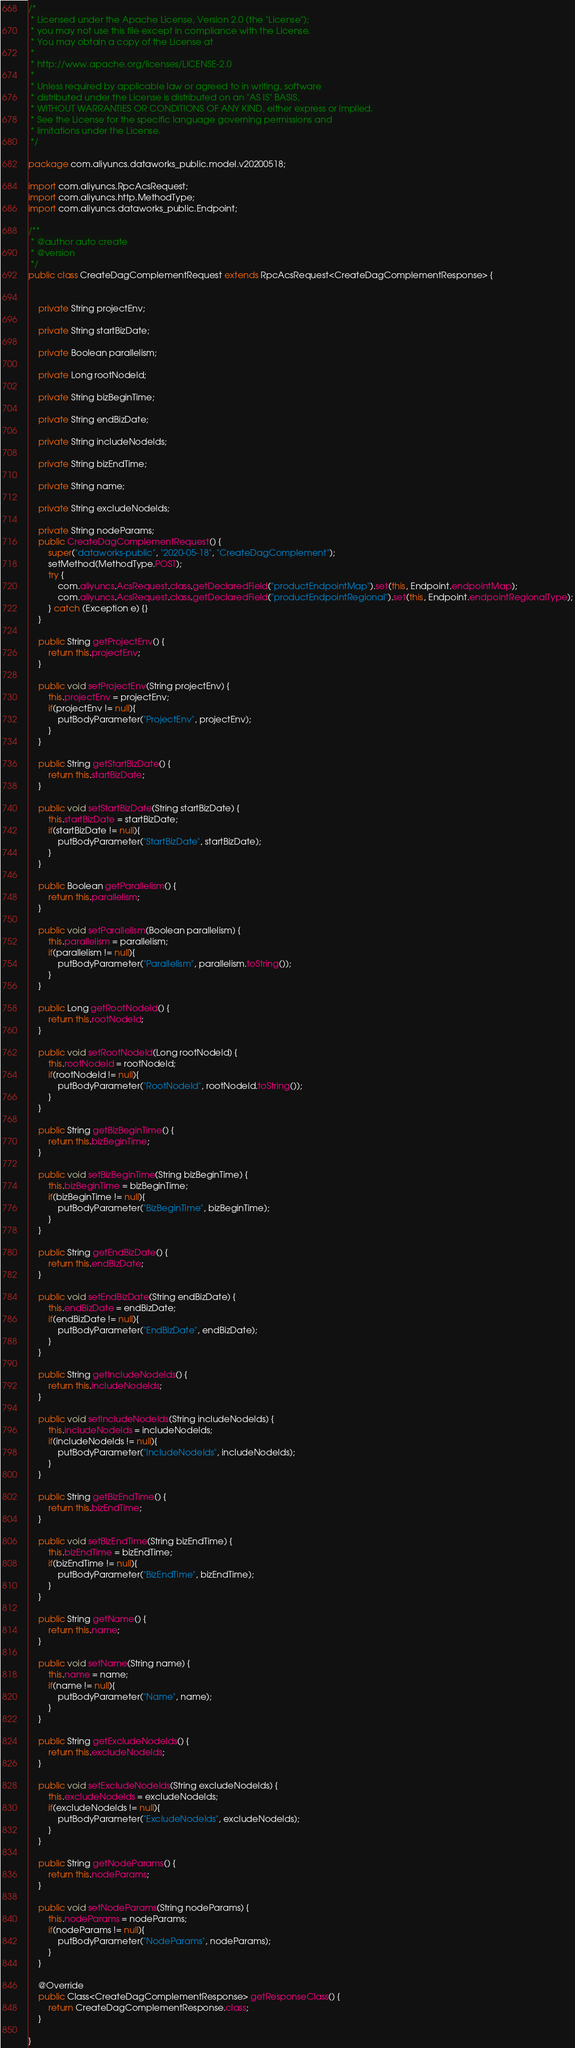<code> <loc_0><loc_0><loc_500><loc_500><_Java_>/*
 * Licensed under the Apache License, Version 2.0 (the "License");
 * you may not use this file except in compliance with the License.
 * You may obtain a copy of the License at
 *
 * http://www.apache.org/licenses/LICENSE-2.0
 *
 * Unless required by applicable law or agreed to in writing, software
 * distributed under the License is distributed on an "AS IS" BASIS,
 * WITHOUT WARRANTIES OR CONDITIONS OF ANY KIND, either express or implied.
 * See the License for the specific language governing permissions and
 * limitations under the License.
 */

package com.aliyuncs.dataworks_public.model.v20200518;

import com.aliyuncs.RpcAcsRequest;
import com.aliyuncs.http.MethodType;
import com.aliyuncs.dataworks_public.Endpoint;

/**
 * @author auto create
 * @version 
 */
public class CreateDagComplementRequest extends RpcAcsRequest<CreateDagComplementResponse> {
	   

	private String projectEnv;

	private String startBizDate;

	private Boolean parallelism;

	private Long rootNodeId;

	private String bizBeginTime;

	private String endBizDate;

	private String includeNodeIds;

	private String bizEndTime;

	private String name;

	private String excludeNodeIds;

	private String nodeParams;
	public CreateDagComplementRequest() {
		super("dataworks-public", "2020-05-18", "CreateDagComplement");
		setMethod(MethodType.POST);
		try {
			com.aliyuncs.AcsRequest.class.getDeclaredField("productEndpointMap").set(this, Endpoint.endpointMap);
			com.aliyuncs.AcsRequest.class.getDeclaredField("productEndpointRegional").set(this, Endpoint.endpointRegionalType);
		} catch (Exception e) {}
	}

	public String getProjectEnv() {
		return this.projectEnv;
	}

	public void setProjectEnv(String projectEnv) {
		this.projectEnv = projectEnv;
		if(projectEnv != null){
			putBodyParameter("ProjectEnv", projectEnv);
		}
	}

	public String getStartBizDate() {
		return this.startBizDate;
	}

	public void setStartBizDate(String startBizDate) {
		this.startBizDate = startBizDate;
		if(startBizDate != null){
			putBodyParameter("StartBizDate", startBizDate);
		}
	}

	public Boolean getParallelism() {
		return this.parallelism;
	}

	public void setParallelism(Boolean parallelism) {
		this.parallelism = parallelism;
		if(parallelism != null){
			putBodyParameter("Parallelism", parallelism.toString());
		}
	}

	public Long getRootNodeId() {
		return this.rootNodeId;
	}

	public void setRootNodeId(Long rootNodeId) {
		this.rootNodeId = rootNodeId;
		if(rootNodeId != null){
			putBodyParameter("RootNodeId", rootNodeId.toString());
		}
	}

	public String getBizBeginTime() {
		return this.bizBeginTime;
	}

	public void setBizBeginTime(String bizBeginTime) {
		this.bizBeginTime = bizBeginTime;
		if(bizBeginTime != null){
			putBodyParameter("BizBeginTime", bizBeginTime);
		}
	}

	public String getEndBizDate() {
		return this.endBizDate;
	}

	public void setEndBizDate(String endBizDate) {
		this.endBizDate = endBizDate;
		if(endBizDate != null){
			putBodyParameter("EndBizDate", endBizDate);
		}
	}

	public String getIncludeNodeIds() {
		return this.includeNodeIds;
	}

	public void setIncludeNodeIds(String includeNodeIds) {
		this.includeNodeIds = includeNodeIds;
		if(includeNodeIds != null){
			putBodyParameter("IncludeNodeIds", includeNodeIds);
		}
	}

	public String getBizEndTime() {
		return this.bizEndTime;
	}

	public void setBizEndTime(String bizEndTime) {
		this.bizEndTime = bizEndTime;
		if(bizEndTime != null){
			putBodyParameter("BizEndTime", bizEndTime);
		}
	}

	public String getName() {
		return this.name;
	}

	public void setName(String name) {
		this.name = name;
		if(name != null){
			putBodyParameter("Name", name);
		}
	}

	public String getExcludeNodeIds() {
		return this.excludeNodeIds;
	}

	public void setExcludeNodeIds(String excludeNodeIds) {
		this.excludeNodeIds = excludeNodeIds;
		if(excludeNodeIds != null){
			putBodyParameter("ExcludeNodeIds", excludeNodeIds);
		}
	}

	public String getNodeParams() {
		return this.nodeParams;
	}

	public void setNodeParams(String nodeParams) {
		this.nodeParams = nodeParams;
		if(nodeParams != null){
			putBodyParameter("NodeParams", nodeParams);
		}
	}

	@Override
	public Class<CreateDagComplementResponse> getResponseClass() {
		return CreateDagComplementResponse.class;
	}

}
</code> 